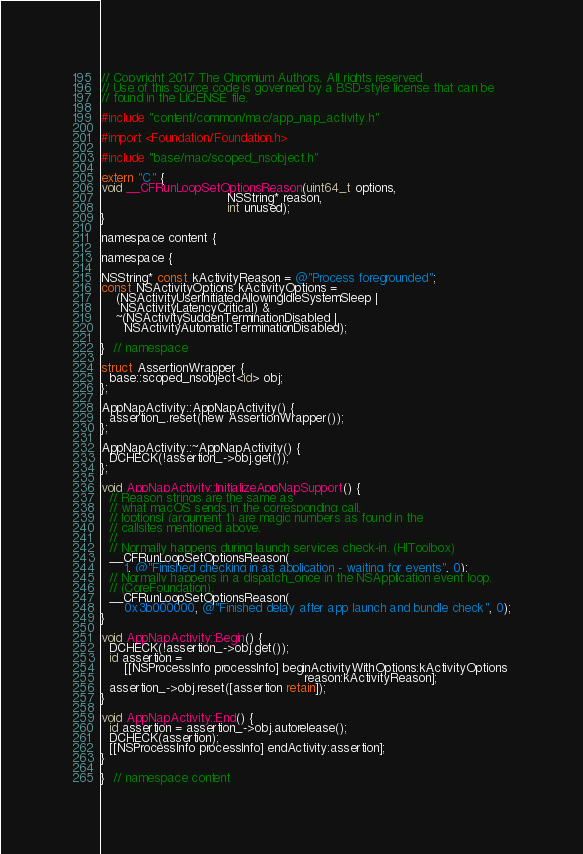<code> <loc_0><loc_0><loc_500><loc_500><_ObjectiveC_>// Copyright 2017 The Chromium Authors. All rights reserved.
// Use of this source code is governed by a BSD-style license that can be
// found in the LICENSE file.

#include "content/common/mac/app_nap_activity.h"

#import <Foundation/Foundation.h>

#include "base/mac/scoped_nsobject.h"

extern "C" {
void __CFRunLoopSetOptionsReason(uint64_t options,
                                 NSString* reason,
                                 int unused);
}

namespace content {

namespace {

NSString* const kActivityReason = @"Process foregrounded";
const NSActivityOptions kActivityOptions =
    (NSActivityUserInitiatedAllowingIdleSystemSleep |
     NSActivityLatencyCritical) &
    ~(NSActivitySuddenTerminationDisabled |
      NSActivityAutomaticTerminationDisabled);

}  // namespace

struct AssertionWrapper {
  base::scoped_nsobject<id> obj;
};

AppNapActivity::AppNapActivity() {
  assertion_.reset(new AssertionWrapper());
};

AppNapActivity::~AppNapActivity() {
  DCHECK(!assertion_->obj.get());
};

void AppNapActivity::InitializeAppNapSupport() {
  // Reason strings are the same as
  // what macOS sends in the corresponding call.
  // |options| (argument 1) are magic numbers as found in the
  // callsites mentioned above.
  //
  // Normally happens during launch services check-in. (HIToolbox)
  __CFRunLoopSetOptionsReason(
      1, @"Finished checking in as application - waiting for events", 0);
  // Normally happens in a dispatch_once in the NSApplication event loop.
  // (CoreFoundation).
  __CFRunLoopSetOptionsReason(
      0x3b000000, @"Finished delay after app launch and bundle check", 0);
}

void AppNapActivity::Begin() {
  DCHECK(!assertion_->obj.get());
  id assertion =
      [[NSProcessInfo processInfo] beginActivityWithOptions:kActivityOptions
                                                     reason:kActivityReason];
  assertion_->obj.reset([assertion retain]);
}

void AppNapActivity::End() {
  id assertion = assertion_->obj.autorelease();
  DCHECK(assertion);
  [[NSProcessInfo processInfo] endActivity:assertion];
}

}  // namespace content
</code> 